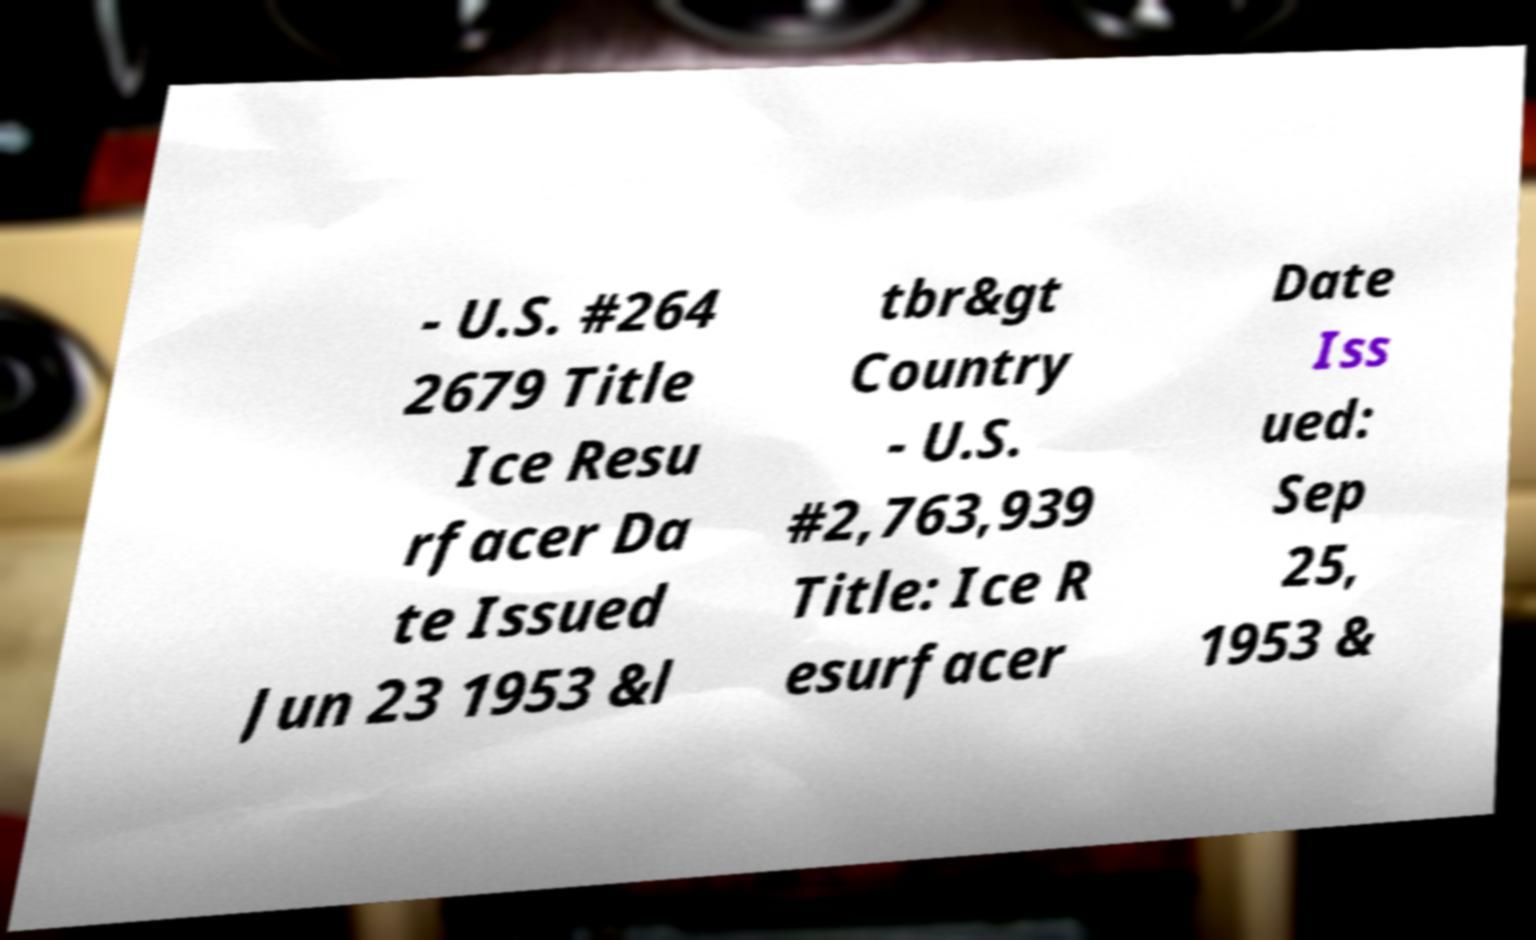Please read and relay the text visible in this image. What does it say? - U.S. #264 2679 Title Ice Resu rfacer Da te Issued Jun 23 1953 &l tbr&gt Country - U.S. #2,763,939 Title: Ice R esurfacer Date Iss ued: Sep 25, 1953 & 